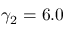Convert formula to latex. <formula><loc_0><loc_0><loc_500><loc_500>\gamma _ { 2 } = 6 . 0</formula> 